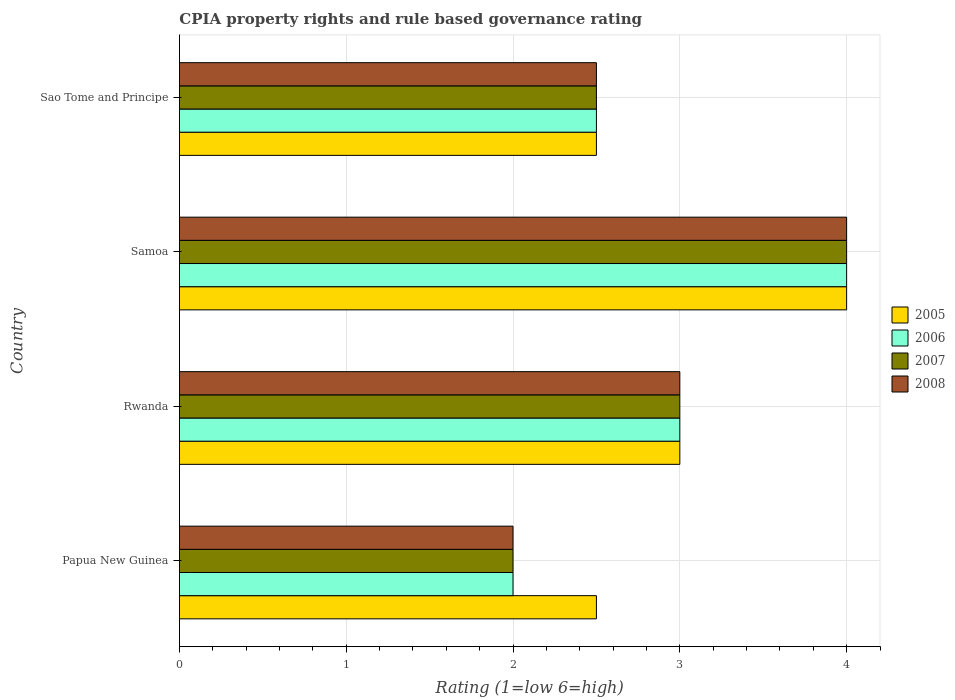How many different coloured bars are there?
Your answer should be compact. 4. Are the number of bars per tick equal to the number of legend labels?
Provide a succinct answer. Yes. Are the number of bars on each tick of the Y-axis equal?
Provide a succinct answer. Yes. How many bars are there on the 1st tick from the bottom?
Your response must be concise. 4. What is the label of the 4th group of bars from the top?
Offer a terse response. Papua New Guinea. Across all countries, what is the minimum CPIA rating in 2007?
Keep it short and to the point. 2. In which country was the CPIA rating in 2008 maximum?
Keep it short and to the point. Samoa. In which country was the CPIA rating in 2007 minimum?
Give a very brief answer. Papua New Guinea. What is the total CPIA rating in 2005 in the graph?
Provide a short and direct response. 12. What is the difference between the CPIA rating in 2007 in Rwanda and that in Samoa?
Make the answer very short. -1. What is the difference between the CPIA rating in 2007 in Papua New Guinea and the CPIA rating in 2005 in Samoa?
Keep it short and to the point. -2. What is the average CPIA rating in 2005 per country?
Keep it short and to the point. 3. In how many countries, is the CPIA rating in 2008 greater than 1 ?
Ensure brevity in your answer.  4. What is the ratio of the CPIA rating in 2006 in Papua New Guinea to that in Samoa?
Your answer should be compact. 0.5. Is the CPIA rating in 2007 in Rwanda less than that in Samoa?
Offer a very short reply. Yes. Is the sum of the CPIA rating in 2006 in Papua New Guinea and Sao Tome and Principe greater than the maximum CPIA rating in 2008 across all countries?
Your response must be concise. Yes. Is it the case that in every country, the sum of the CPIA rating in 2005 and CPIA rating in 2007 is greater than the sum of CPIA rating in 2006 and CPIA rating in 2008?
Give a very brief answer. No. Is it the case that in every country, the sum of the CPIA rating in 2008 and CPIA rating in 2006 is greater than the CPIA rating in 2007?
Your answer should be very brief. Yes. How many bars are there?
Your answer should be very brief. 16. What is the difference between two consecutive major ticks on the X-axis?
Keep it short and to the point. 1. Does the graph contain any zero values?
Give a very brief answer. No. Does the graph contain grids?
Make the answer very short. Yes. How many legend labels are there?
Provide a short and direct response. 4. What is the title of the graph?
Provide a succinct answer. CPIA property rights and rule based governance rating. Does "1988" appear as one of the legend labels in the graph?
Keep it short and to the point. No. What is the label or title of the Y-axis?
Provide a succinct answer. Country. What is the Rating (1=low 6=high) of 2006 in Papua New Guinea?
Ensure brevity in your answer.  2. What is the Rating (1=low 6=high) of 2007 in Papua New Guinea?
Your response must be concise. 2. What is the Rating (1=low 6=high) of 2008 in Papua New Guinea?
Offer a very short reply. 2. What is the Rating (1=low 6=high) of 2008 in Rwanda?
Give a very brief answer. 3. What is the Rating (1=low 6=high) of 2005 in Samoa?
Your response must be concise. 4. What is the Rating (1=low 6=high) in 2006 in Samoa?
Your answer should be very brief. 4. What is the Rating (1=low 6=high) in 2007 in Samoa?
Ensure brevity in your answer.  4. What is the Rating (1=low 6=high) in 2005 in Sao Tome and Principe?
Your response must be concise. 2.5. What is the Rating (1=low 6=high) of 2006 in Sao Tome and Principe?
Offer a very short reply. 2.5. What is the Rating (1=low 6=high) of 2008 in Sao Tome and Principe?
Your answer should be very brief. 2.5. Across all countries, what is the maximum Rating (1=low 6=high) in 2007?
Offer a very short reply. 4. Across all countries, what is the minimum Rating (1=low 6=high) in 2005?
Ensure brevity in your answer.  2.5. Across all countries, what is the minimum Rating (1=low 6=high) of 2006?
Your answer should be compact. 2. Across all countries, what is the minimum Rating (1=low 6=high) in 2007?
Ensure brevity in your answer.  2. Across all countries, what is the minimum Rating (1=low 6=high) of 2008?
Your answer should be compact. 2. What is the total Rating (1=low 6=high) of 2006 in the graph?
Offer a terse response. 11.5. What is the total Rating (1=low 6=high) of 2007 in the graph?
Your response must be concise. 11.5. What is the difference between the Rating (1=low 6=high) of 2006 in Papua New Guinea and that in Rwanda?
Offer a terse response. -1. What is the difference between the Rating (1=low 6=high) of 2008 in Papua New Guinea and that in Rwanda?
Your answer should be very brief. -1. What is the difference between the Rating (1=low 6=high) in 2007 in Papua New Guinea and that in Samoa?
Give a very brief answer. -2. What is the difference between the Rating (1=low 6=high) of 2005 in Papua New Guinea and that in Sao Tome and Principe?
Give a very brief answer. 0. What is the difference between the Rating (1=low 6=high) in 2006 in Papua New Guinea and that in Sao Tome and Principe?
Make the answer very short. -0.5. What is the difference between the Rating (1=low 6=high) of 2008 in Papua New Guinea and that in Sao Tome and Principe?
Your response must be concise. -0.5. What is the difference between the Rating (1=low 6=high) of 2007 in Rwanda and that in Samoa?
Ensure brevity in your answer.  -1. What is the difference between the Rating (1=low 6=high) in 2008 in Rwanda and that in Samoa?
Your answer should be very brief. -1. What is the difference between the Rating (1=low 6=high) of 2005 in Rwanda and that in Sao Tome and Principe?
Ensure brevity in your answer.  0.5. What is the difference between the Rating (1=low 6=high) of 2006 in Rwanda and that in Sao Tome and Principe?
Offer a very short reply. 0.5. What is the difference between the Rating (1=low 6=high) in 2007 in Rwanda and that in Sao Tome and Principe?
Your answer should be very brief. 0.5. What is the difference between the Rating (1=low 6=high) in 2005 in Samoa and that in Sao Tome and Principe?
Keep it short and to the point. 1.5. What is the difference between the Rating (1=low 6=high) of 2007 in Samoa and that in Sao Tome and Principe?
Give a very brief answer. 1.5. What is the difference between the Rating (1=low 6=high) of 2007 in Papua New Guinea and the Rating (1=low 6=high) of 2008 in Rwanda?
Keep it short and to the point. -1. What is the difference between the Rating (1=low 6=high) of 2005 in Papua New Guinea and the Rating (1=low 6=high) of 2006 in Samoa?
Give a very brief answer. -1.5. What is the difference between the Rating (1=low 6=high) in 2006 in Papua New Guinea and the Rating (1=low 6=high) in 2008 in Samoa?
Your answer should be very brief. -2. What is the difference between the Rating (1=low 6=high) of 2006 in Papua New Guinea and the Rating (1=low 6=high) of 2007 in Sao Tome and Principe?
Keep it short and to the point. -0.5. What is the difference between the Rating (1=low 6=high) of 2006 in Papua New Guinea and the Rating (1=low 6=high) of 2008 in Sao Tome and Principe?
Offer a very short reply. -0.5. What is the difference between the Rating (1=low 6=high) in 2005 in Rwanda and the Rating (1=low 6=high) in 2008 in Samoa?
Make the answer very short. -1. What is the difference between the Rating (1=low 6=high) in 2006 in Rwanda and the Rating (1=low 6=high) in 2007 in Samoa?
Offer a terse response. -1. What is the difference between the Rating (1=low 6=high) in 2006 in Rwanda and the Rating (1=low 6=high) in 2008 in Samoa?
Offer a very short reply. -1. What is the difference between the Rating (1=low 6=high) in 2005 in Rwanda and the Rating (1=low 6=high) in 2006 in Sao Tome and Principe?
Provide a succinct answer. 0.5. What is the difference between the Rating (1=low 6=high) in 2005 in Rwanda and the Rating (1=low 6=high) in 2007 in Sao Tome and Principe?
Your answer should be compact. 0.5. What is the difference between the Rating (1=low 6=high) of 2005 in Rwanda and the Rating (1=low 6=high) of 2008 in Sao Tome and Principe?
Ensure brevity in your answer.  0.5. What is the difference between the Rating (1=low 6=high) of 2006 in Rwanda and the Rating (1=low 6=high) of 2007 in Sao Tome and Principe?
Your answer should be compact. 0.5. What is the difference between the Rating (1=low 6=high) in 2006 in Rwanda and the Rating (1=low 6=high) in 2008 in Sao Tome and Principe?
Offer a terse response. 0.5. What is the difference between the Rating (1=low 6=high) of 2005 in Samoa and the Rating (1=low 6=high) of 2008 in Sao Tome and Principe?
Provide a succinct answer. 1.5. What is the difference between the Rating (1=low 6=high) in 2006 in Samoa and the Rating (1=low 6=high) in 2007 in Sao Tome and Principe?
Offer a terse response. 1.5. What is the difference between the Rating (1=low 6=high) of 2006 in Samoa and the Rating (1=low 6=high) of 2008 in Sao Tome and Principe?
Provide a short and direct response. 1.5. What is the difference between the Rating (1=low 6=high) of 2007 in Samoa and the Rating (1=low 6=high) of 2008 in Sao Tome and Principe?
Make the answer very short. 1.5. What is the average Rating (1=low 6=high) of 2005 per country?
Offer a very short reply. 3. What is the average Rating (1=low 6=high) of 2006 per country?
Your answer should be compact. 2.88. What is the average Rating (1=low 6=high) in 2007 per country?
Your response must be concise. 2.88. What is the average Rating (1=low 6=high) in 2008 per country?
Your answer should be compact. 2.88. What is the difference between the Rating (1=low 6=high) of 2005 and Rating (1=low 6=high) of 2006 in Papua New Guinea?
Provide a short and direct response. 0.5. What is the difference between the Rating (1=low 6=high) in 2005 and Rating (1=low 6=high) in 2008 in Papua New Guinea?
Your response must be concise. 0.5. What is the difference between the Rating (1=low 6=high) in 2006 and Rating (1=low 6=high) in 2007 in Papua New Guinea?
Provide a succinct answer. 0. What is the difference between the Rating (1=low 6=high) of 2005 and Rating (1=low 6=high) of 2008 in Rwanda?
Your answer should be very brief. 0. What is the difference between the Rating (1=low 6=high) of 2006 and Rating (1=low 6=high) of 2007 in Rwanda?
Provide a succinct answer. 0. What is the difference between the Rating (1=low 6=high) in 2007 and Rating (1=low 6=high) in 2008 in Rwanda?
Ensure brevity in your answer.  0. What is the difference between the Rating (1=low 6=high) of 2005 and Rating (1=low 6=high) of 2007 in Sao Tome and Principe?
Offer a terse response. 0. What is the difference between the Rating (1=low 6=high) in 2005 and Rating (1=low 6=high) in 2008 in Sao Tome and Principe?
Your answer should be compact. 0. What is the ratio of the Rating (1=low 6=high) of 2005 in Papua New Guinea to that in Rwanda?
Make the answer very short. 0.83. What is the ratio of the Rating (1=low 6=high) in 2008 in Papua New Guinea to that in Rwanda?
Offer a terse response. 0.67. What is the ratio of the Rating (1=low 6=high) of 2005 in Papua New Guinea to that in Samoa?
Make the answer very short. 0.62. What is the ratio of the Rating (1=low 6=high) of 2006 in Papua New Guinea to that in Samoa?
Make the answer very short. 0.5. What is the ratio of the Rating (1=low 6=high) in 2005 in Papua New Guinea to that in Sao Tome and Principe?
Provide a short and direct response. 1. What is the ratio of the Rating (1=low 6=high) of 2008 in Papua New Guinea to that in Sao Tome and Principe?
Give a very brief answer. 0.8. What is the ratio of the Rating (1=low 6=high) in 2006 in Rwanda to that in Samoa?
Ensure brevity in your answer.  0.75. What is the ratio of the Rating (1=low 6=high) of 2005 in Rwanda to that in Sao Tome and Principe?
Your answer should be very brief. 1.2. What is the ratio of the Rating (1=low 6=high) of 2005 in Samoa to that in Sao Tome and Principe?
Your response must be concise. 1.6. What is the ratio of the Rating (1=low 6=high) of 2007 in Samoa to that in Sao Tome and Principe?
Your answer should be compact. 1.6. What is the difference between the highest and the lowest Rating (1=low 6=high) in 2007?
Your response must be concise. 2. 